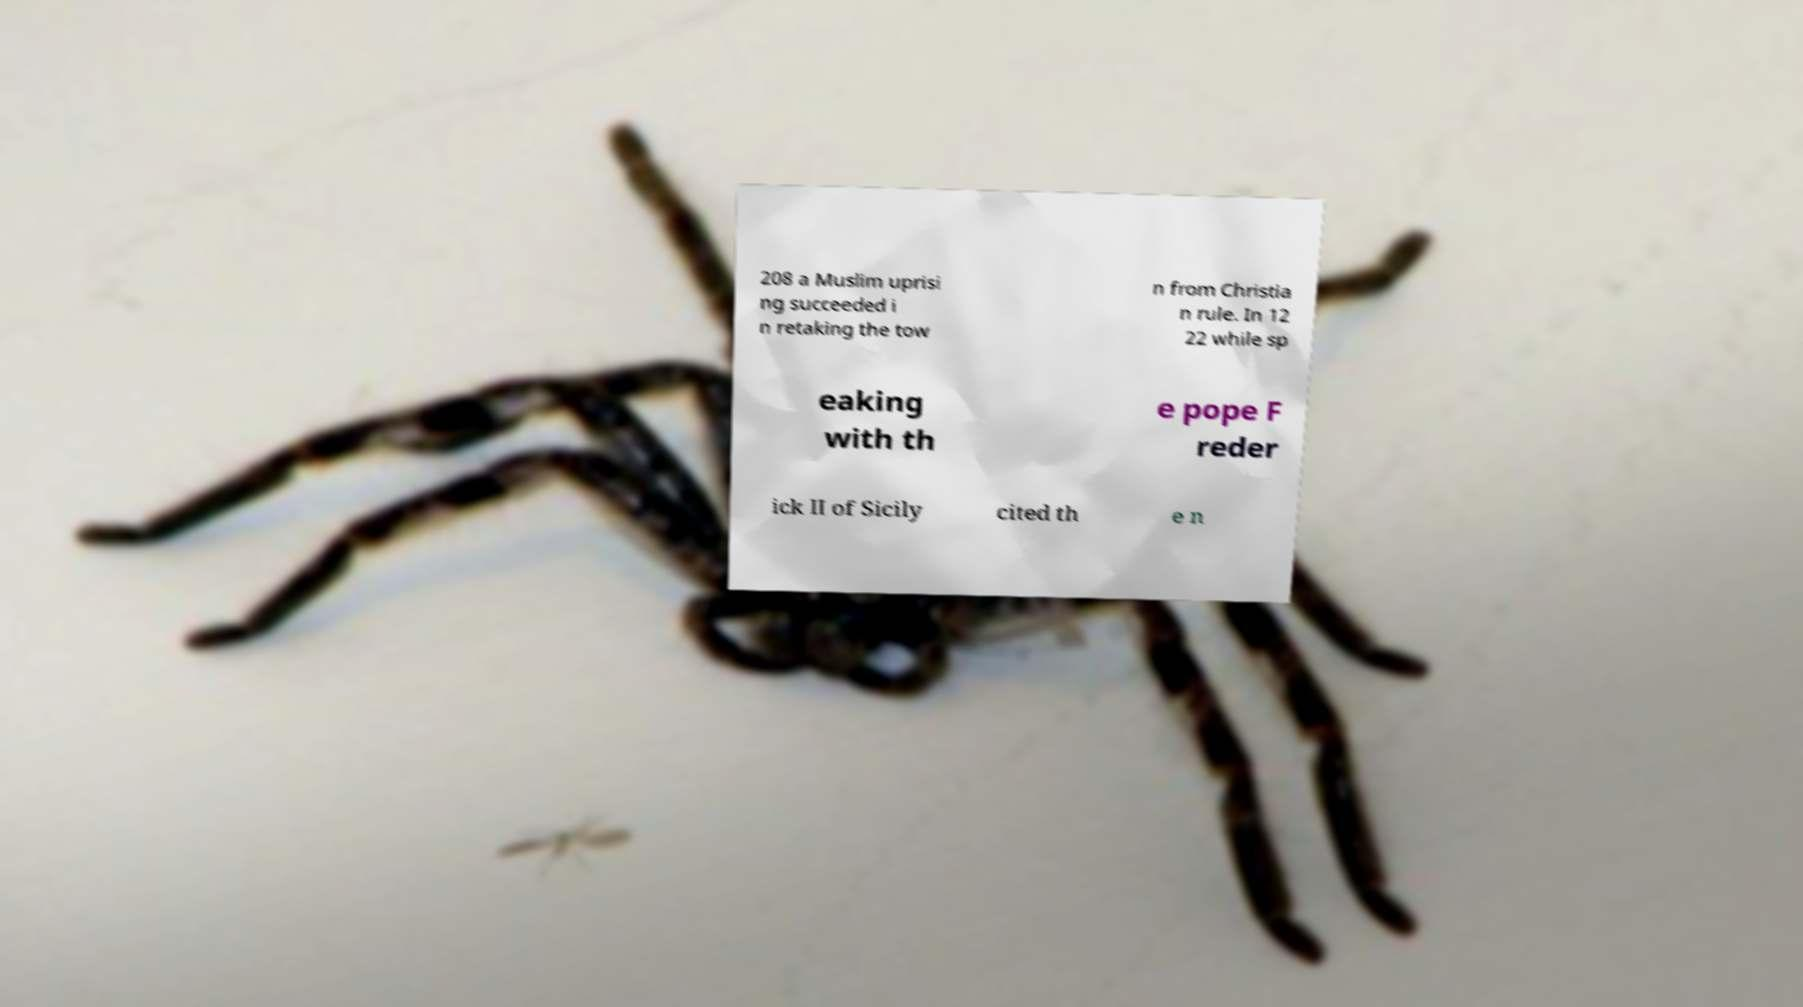Could you assist in decoding the text presented in this image and type it out clearly? 208 a Muslim uprisi ng succeeded i n retaking the tow n from Christia n rule. In 12 22 while sp eaking with th e pope F reder ick II of Sicily cited th e n 